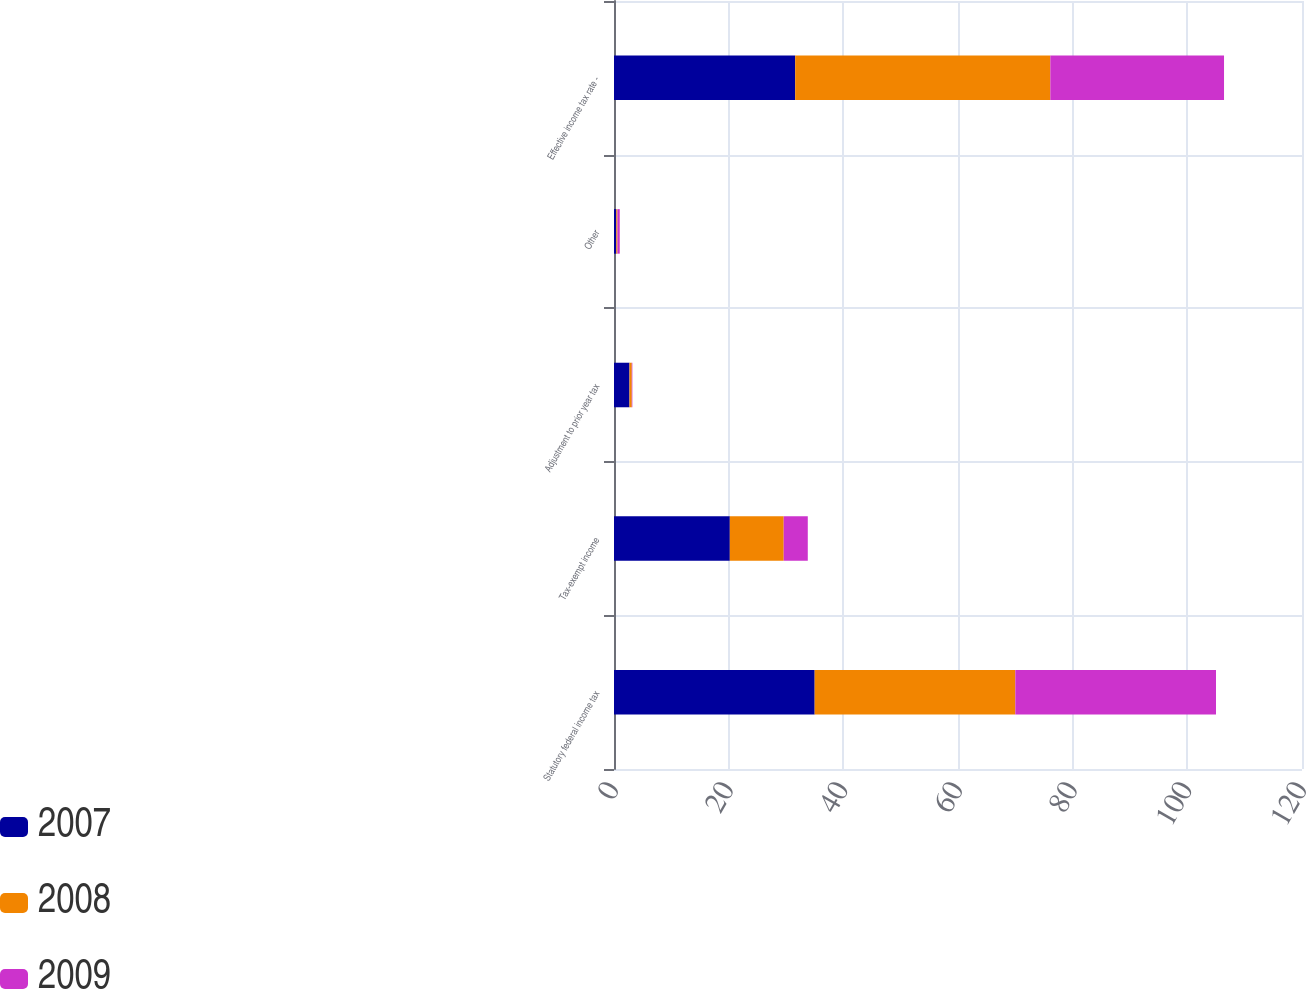<chart> <loc_0><loc_0><loc_500><loc_500><stacked_bar_chart><ecel><fcel>Statutory federal income tax<fcel>Tax-exempt income<fcel>Adjustment to prior year tax<fcel>Other<fcel>Effective income tax rate -<nl><fcel>2007<fcel>35<fcel>20.2<fcel>2.7<fcel>0.4<fcel>31.6<nl><fcel>2008<fcel>35<fcel>9.4<fcel>0.4<fcel>0.2<fcel>44.5<nl><fcel>2009<fcel>35<fcel>4.2<fcel>0.1<fcel>0.4<fcel>30.3<nl></chart> 